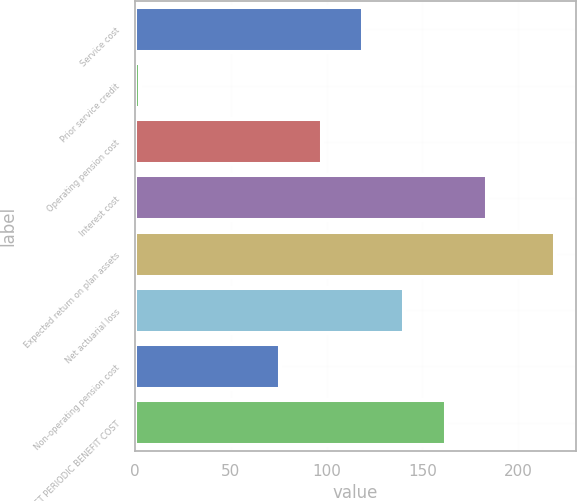<chart> <loc_0><loc_0><loc_500><loc_500><bar_chart><fcel>Service cost<fcel>Prior service credit<fcel>Operating pension cost<fcel>Interest cost<fcel>Expected return on plan assets<fcel>Net actuarial loss<fcel>Non-operating pension cost<fcel>NET PERIODIC BENEFIT COST<nl><fcel>119.06<fcel>2.8<fcel>97.43<fcel>183.95<fcel>219.1<fcel>140.69<fcel>75.8<fcel>162.32<nl></chart> 